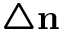Convert formula to latex. <formula><loc_0><loc_0><loc_500><loc_500>\triangle n</formula> 